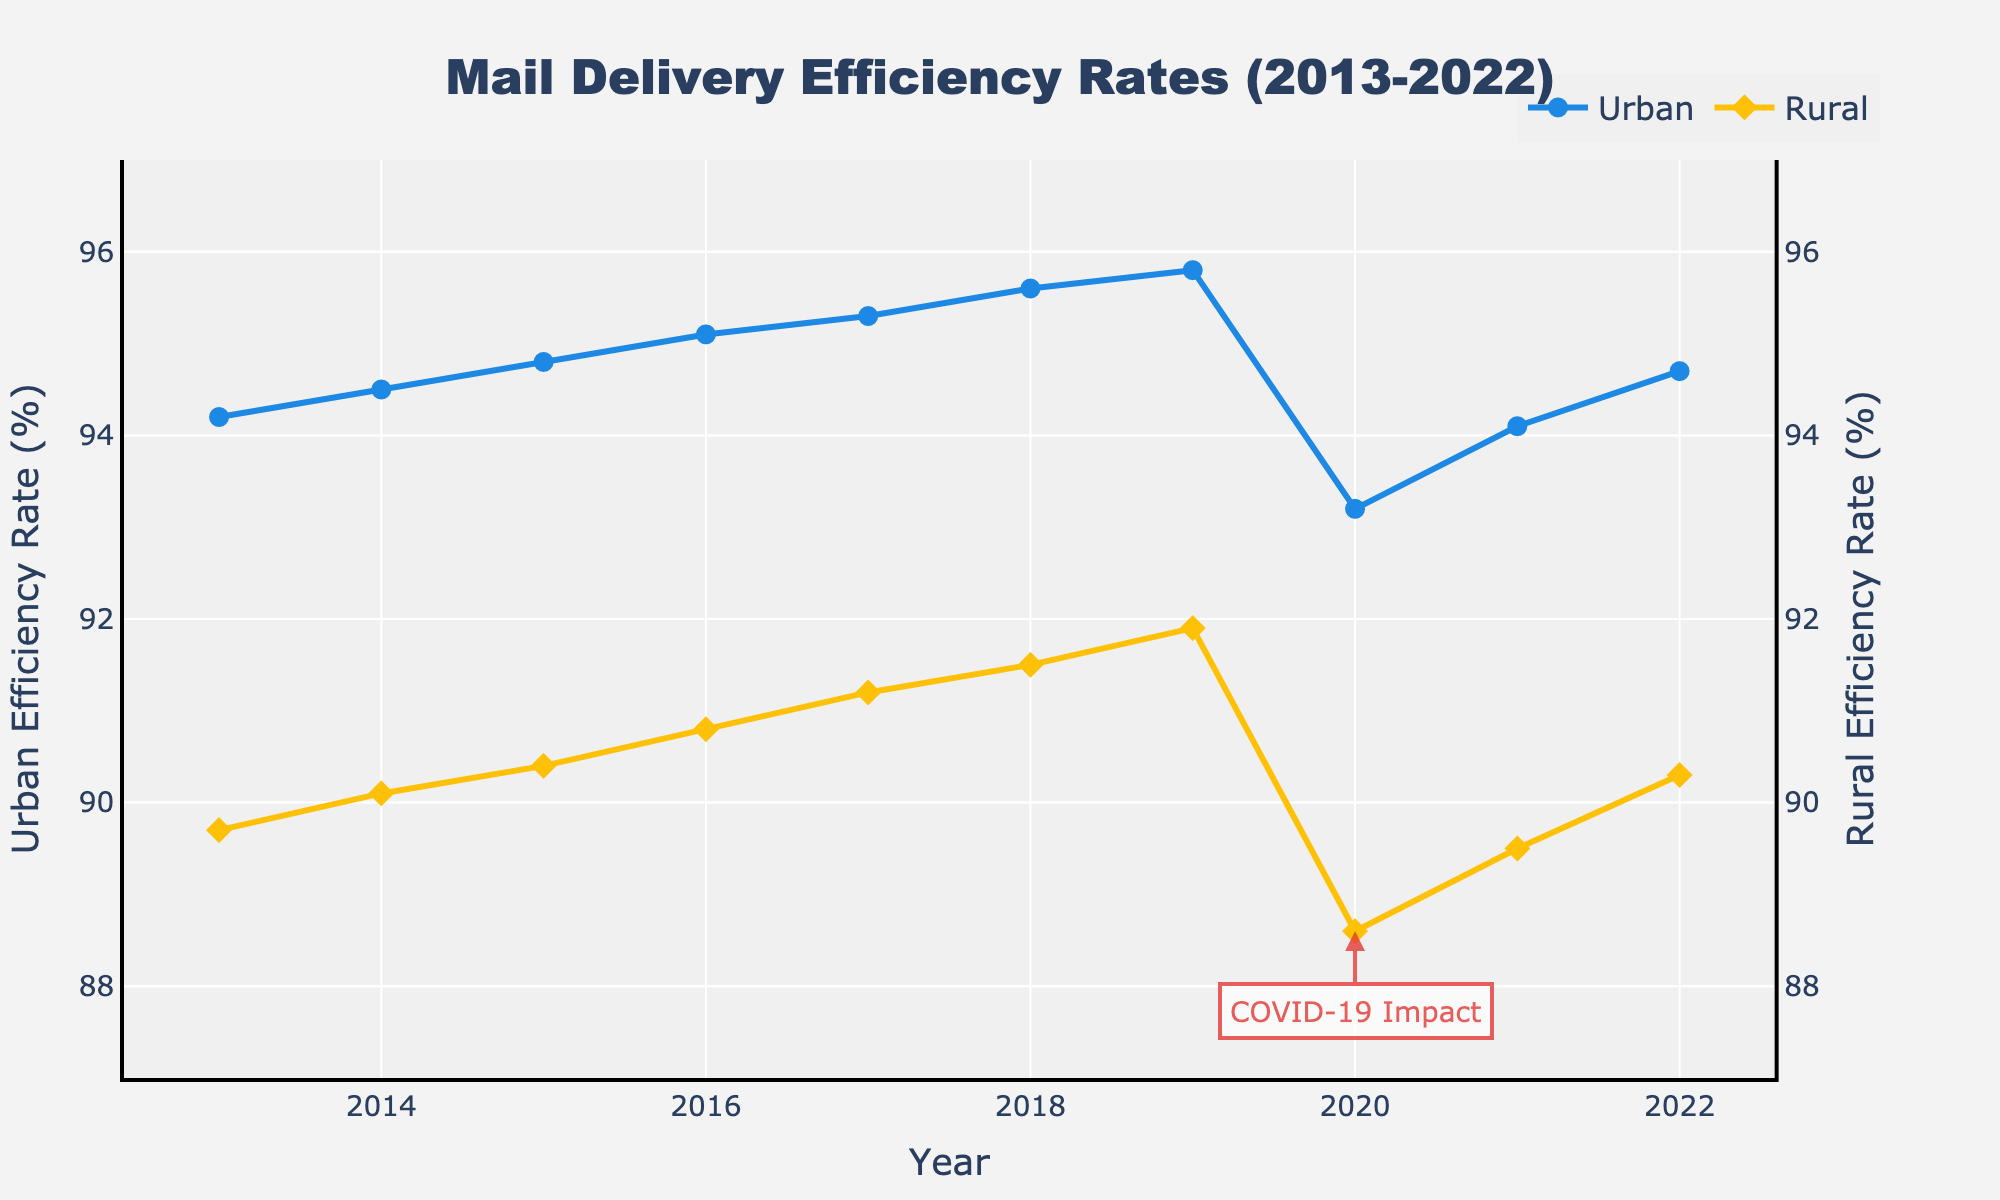What's the general trend of mail delivery efficiency rates in urban areas from 2013 to 2022? The urban efficiency rate shows a general increasing trend from 2013 to 2022. It rises from 94.2% to 95.8% until 2019, drops to 93.2% in 2020, and then rises again to 94.7% by 2022.
Answer: Increasing trend, with a dip in 2020 Did the rural mail delivery efficiency rate ever surpass the urban mail delivery efficiency rate from 2013 to 2022? By examining the visual lines, the rural efficiency rate is consistently below the urban efficiency rate across all years.
Answer: No In which year did the urban mail delivery efficiency rate experience the most significant drop, and what was the rate? According to the annotation and visible drop, the most significant decrease in urban efficiency occurred in 2020, dropping to 93.2%.
Answer: 2020, 93.2% What is the difference in mail delivery efficiency rates between urban and rural areas in 2020? The efficiency rate for urban areas in 2020 was 93.2%, and for rural areas, it was 88.6%. The difference is calculated as 93.2 - 88.6 = 4.6%.
Answer: 4.6% Compare the efficiency rates of urban and rural areas in 2017. Which one is higher and by how much? The urban efficiency rate in 2017 was 95.3%, and the rural efficiency rate was 91.2%. The difference is 95.3 - 91.2 = 4.1%, with urban being higher.
Answer: Urban is higher by 4.1% What are the efficiency rates for urban and rural areas in the last recorded year, 2022? In 2022, the efficiency rate for urban areas is 94.7% and for rural areas, it is 90.3%. These values can be directly read from the chart.
Answer: 94.7% (Urban), 90.3% (Rural) Calculate the average rural mail delivery efficiency rate over the period from 2013 to 2022. Summing rural rates from each year: 89.7 + 90.1 + 90.4 + 90.8 + 91.2 + 91.5 + 91.9 + 88.6 + 89.5 + 90.3 = 903. With 10 years, the average is 903/10.
Answer: 90.3% How did the gap between urban and rural mail delivery efficiency rates change from 2013 to 2022? In 2013, the difference was 94.2 - 89.7 = 4.5%. In 2022, the difference was 94.7 - 90.3 = 4.4%. The change was 4.5% - 4.4% = 0.1%.
Answer: Decreased by 0.1% Which year had the smallest gap between urban and rural efficiency rates? The smallest gap appears to be in 2019 with urban at 95.8% and rural at 91.9%. The difference is 95.8 - 91.9 = 3.9%, which is the smallest gap.
Answer: 2019 